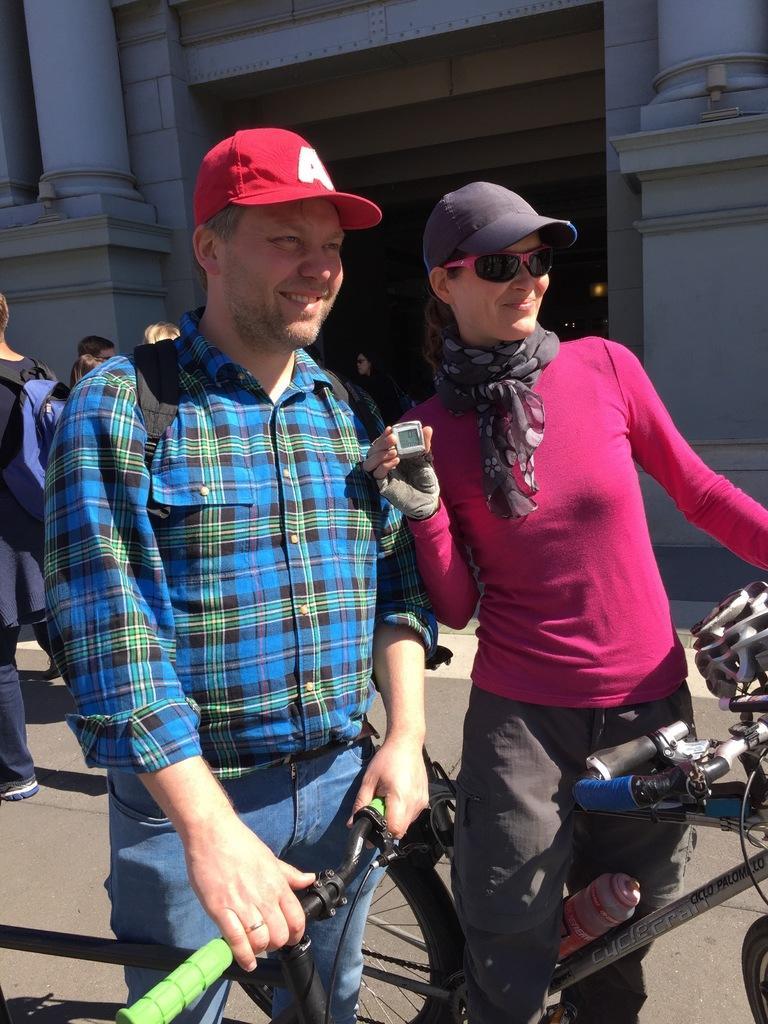Please provide a concise description of this image. In this image I can see 2 people standing, wearing caps and holding bicycles. There are other people and a building at the back. The building has pillars. 